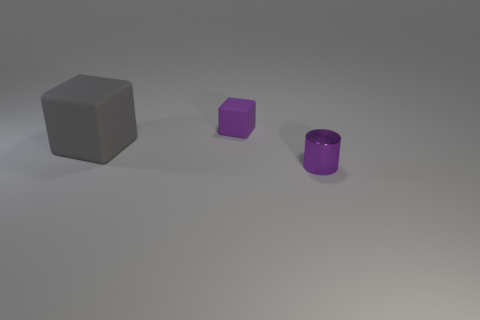Add 3 small cyan objects. How many objects exist? 6 Subtract all blocks. How many objects are left? 1 Add 1 large green matte balls. How many large green matte balls exist? 1 Subtract 0 brown blocks. How many objects are left? 3 Subtract all yellow cubes. Subtract all small things. How many objects are left? 1 Add 2 small purple cubes. How many small purple cubes are left? 3 